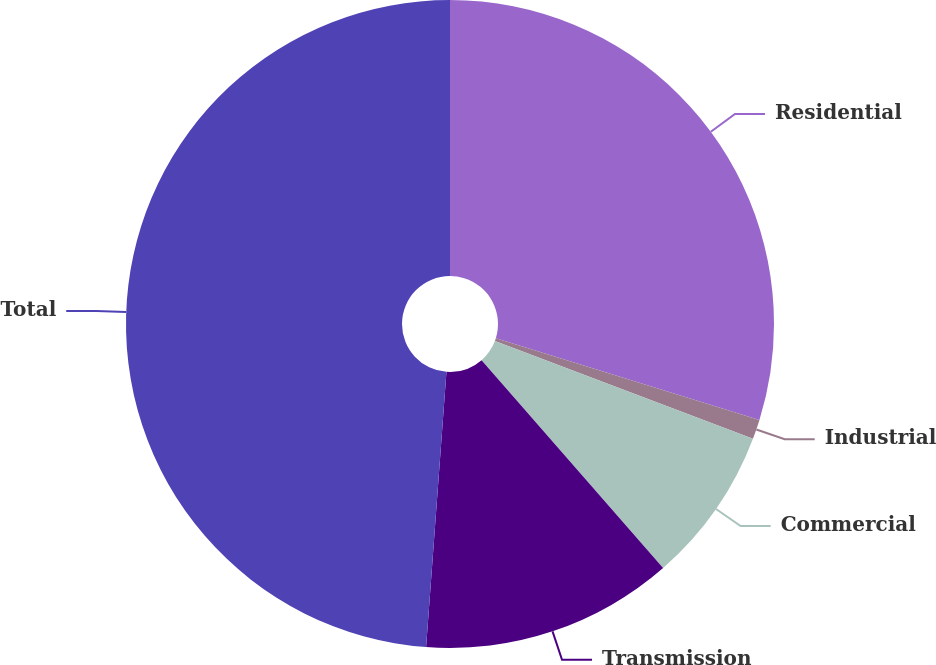Convert chart. <chart><loc_0><loc_0><loc_500><loc_500><pie_chart><fcel>Residential<fcel>Industrial<fcel>Commercial<fcel>Transmission<fcel>Total<nl><fcel>29.79%<fcel>0.98%<fcel>7.81%<fcel>12.6%<fcel>48.83%<nl></chart> 